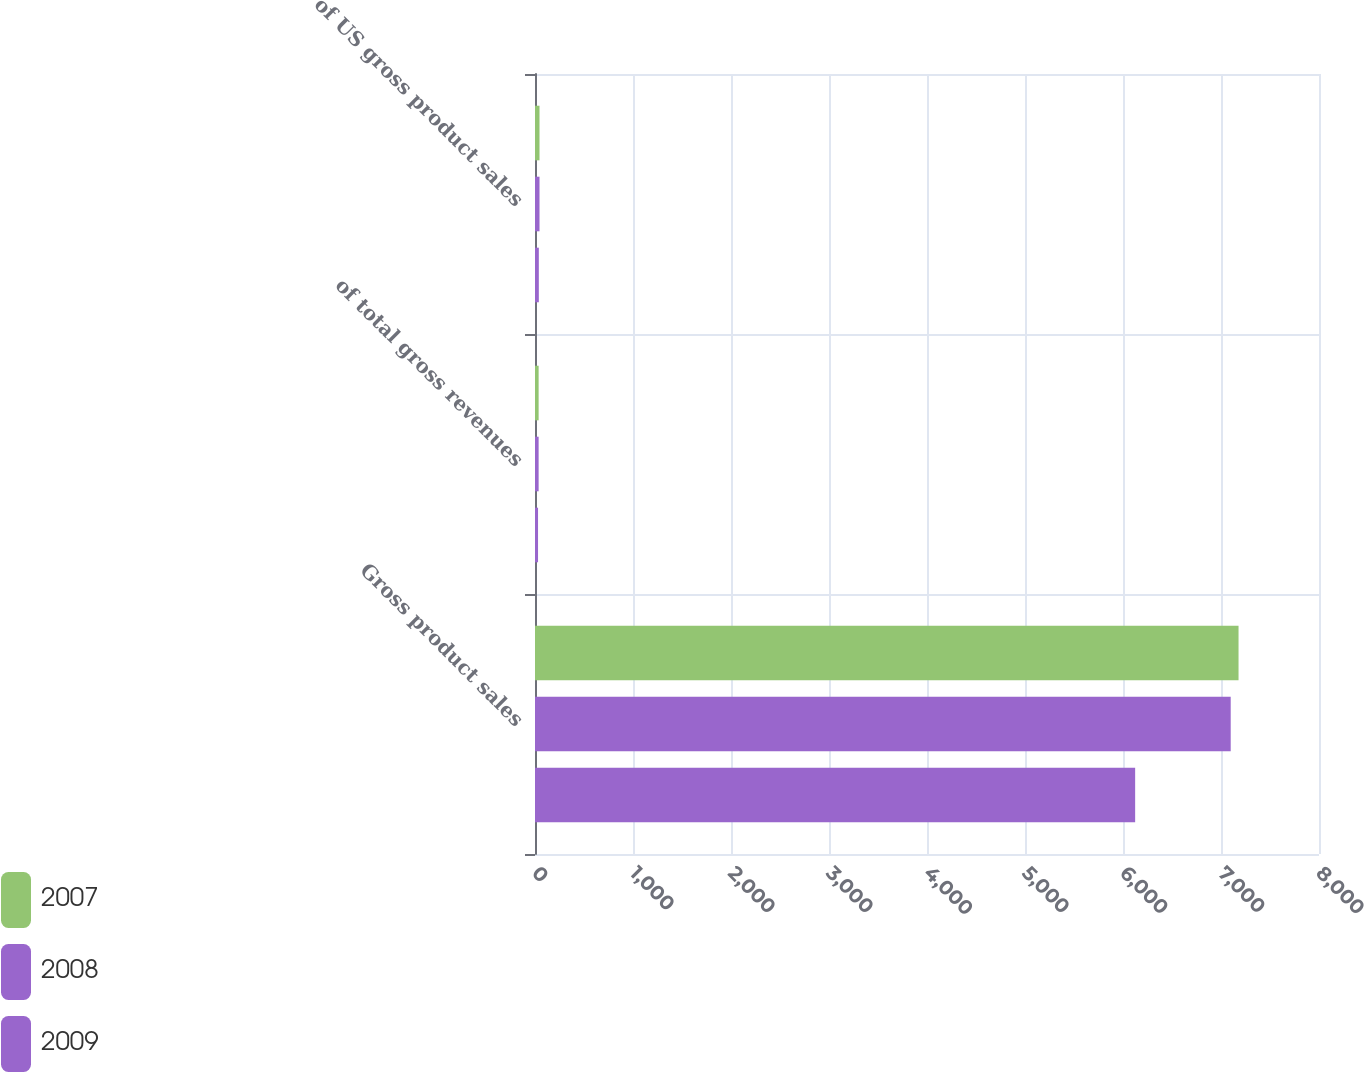Convert chart. <chart><loc_0><loc_0><loc_500><loc_500><stacked_bar_chart><ecel><fcel>Gross product sales<fcel>of total gross revenues<fcel>of US gross product sales<nl><fcel>2007<fcel>7179<fcel>37<fcel>46<nl><fcel>2008<fcel>7099<fcel>37<fcel>46<nl><fcel>2009<fcel>6124<fcel>31<fcel>39<nl></chart> 